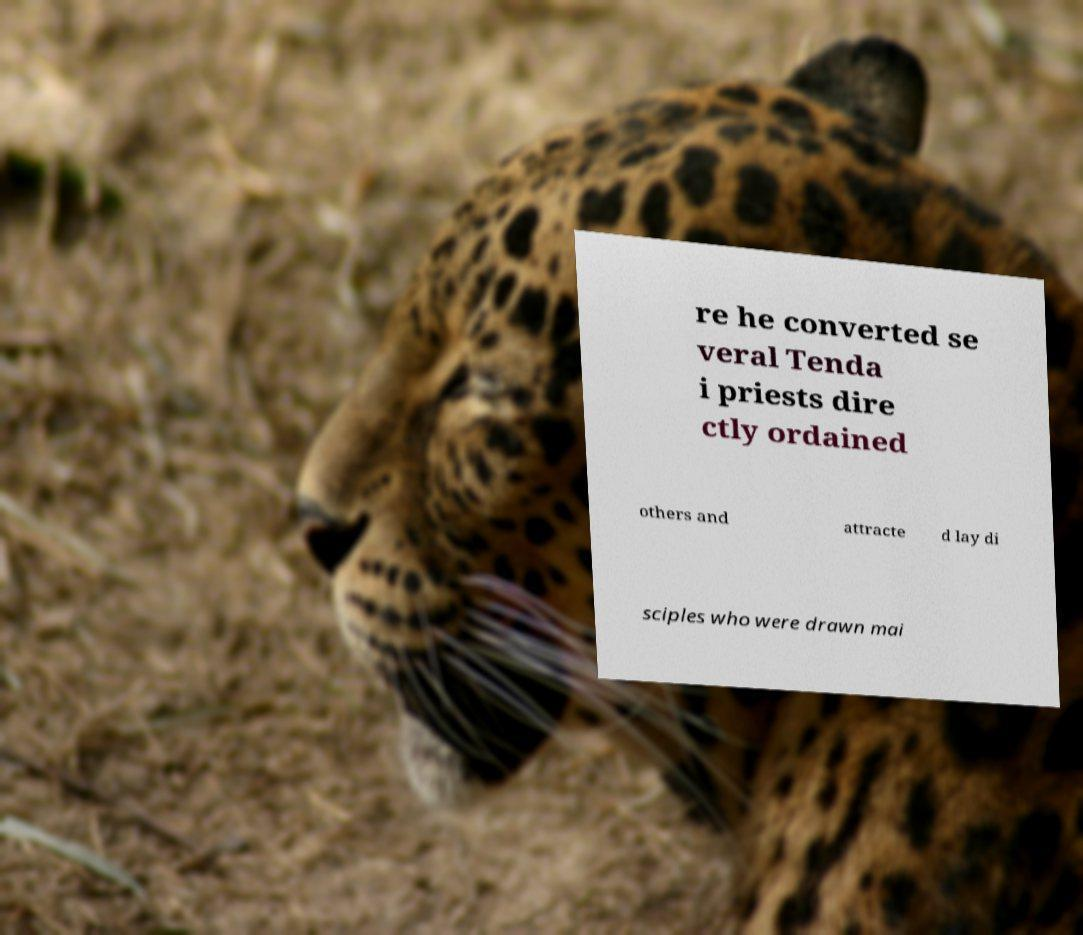Could you assist in decoding the text presented in this image and type it out clearly? re he converted se veral Tenda i priests dire ctly ordained others and attracte d lay di sciples who were drawn mai 